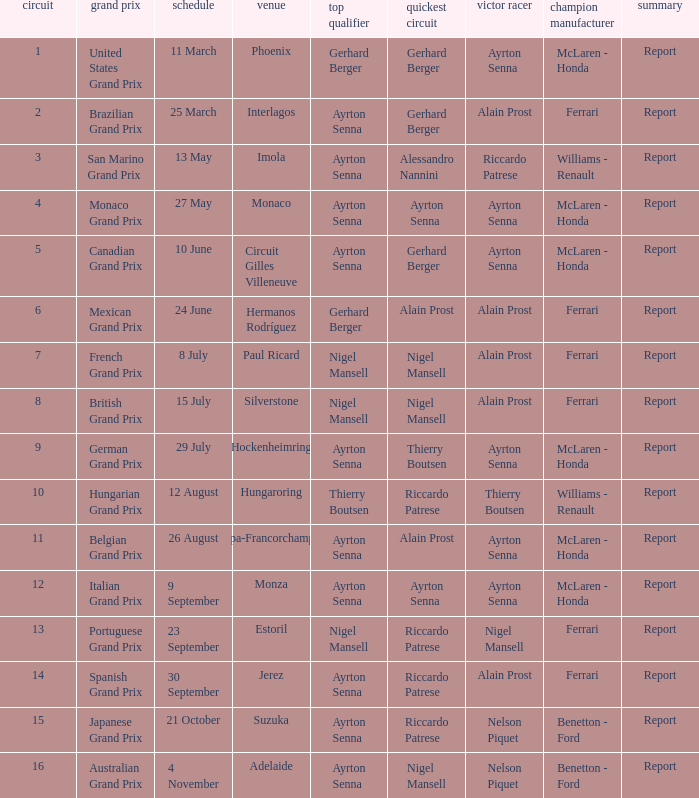What was the constructor when riccardo patrese was the winning driver? Williams - Renault. 